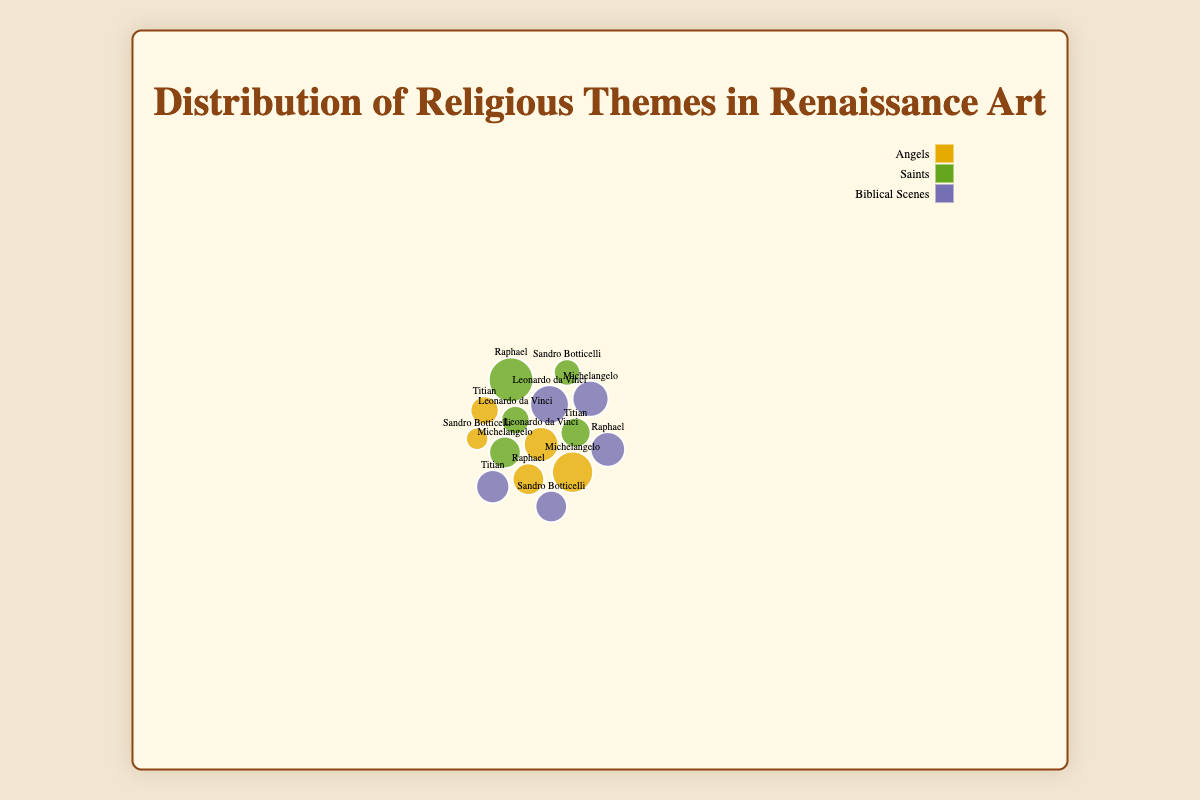What is the motif with the highest frequency for Leonardo da Vinci? By observing the bubble size for each motif related to Leonardo da Vinci, the "Biblical Scenes" bubble has the largest size, indicating the highest frequency.
Answer: Biblical Scenes What is the total frequency of all motifs for Raphael? Sum the frequency of "Angels" (10), "Saints" (20), and "Biblical Scenes" (12) for Raphael: 10 + 20 + 12 = 42.
Answer: 42 Which artist has the most depictions of Saints? Comparing the bubble sizes specific to Saints across all artists, Raphael's bubble is the largest.
Answer: Raphael How does Michelangelo's frequency of Angels compare to Leonardo da Vinci's? Michelangelo's "Angels" bubble has a size corresponding to a frequency of 17, while Leonardo da Vinci's is 12. Thus, Michelangelo has more depictions of Angels.
Answer: Michelangelo's is higher Rank the artists by the frequency of their "Biblical Scenes" motif from highest to lowest. By comparing the bubble sizes of "Biblical Scenes" for each artist: Leonardo da Vinci (15), Michelangelo (13), Raphael (12), Titian (11), Sandro Botticelli (10).
Answer: Leonardo da Vinci, Michelangelo, Raphael, Titian, Sandro Botticelli What is the average frequency of the "Angels" motif across all artists? Sum the frequencies of "Angels" for all artists: 12 (Leonardo da Vinci) + 17 (Michelangelo) + 10 (Raphael) + 5 (Sandro Botticelli) + 8 (Titian) = 52. There are 5 artists, so the average is 52/5 = 10.4.
Answer: 10.4 Which motif is depicted the least frequently by Sandro Botticelli? By examining the smallest bubble size for Sandro Botticelli, "Angels" has the smallest frequency.
Answer: Angels What is the difference in frequency of "Saints" between Michelangelo and Sandro Botticelli? The frequency of "Saints" for Michelangelo is 10 and for Sandro Botticelli is 7. The difference is 10 - 7 = 3.
Answer: 3 Which artist has the smallest total frequency across all motifs? Sum each artist's motif frequencies and compare: 
Leonardo da Vinci: 12 + 8 + 15 = 35, 
Michelangelo: 17 + 10 + 13 = 40, 
Raphael: 10 + 20 + 12 = 42, 
Sandro Botticelli: 5 + 7 + 10 = 22, 
Titian: 8 + 9 + 11 = 28.
Sandro Botticelli has the smallest total.
Answer: Sandro Botticelli 